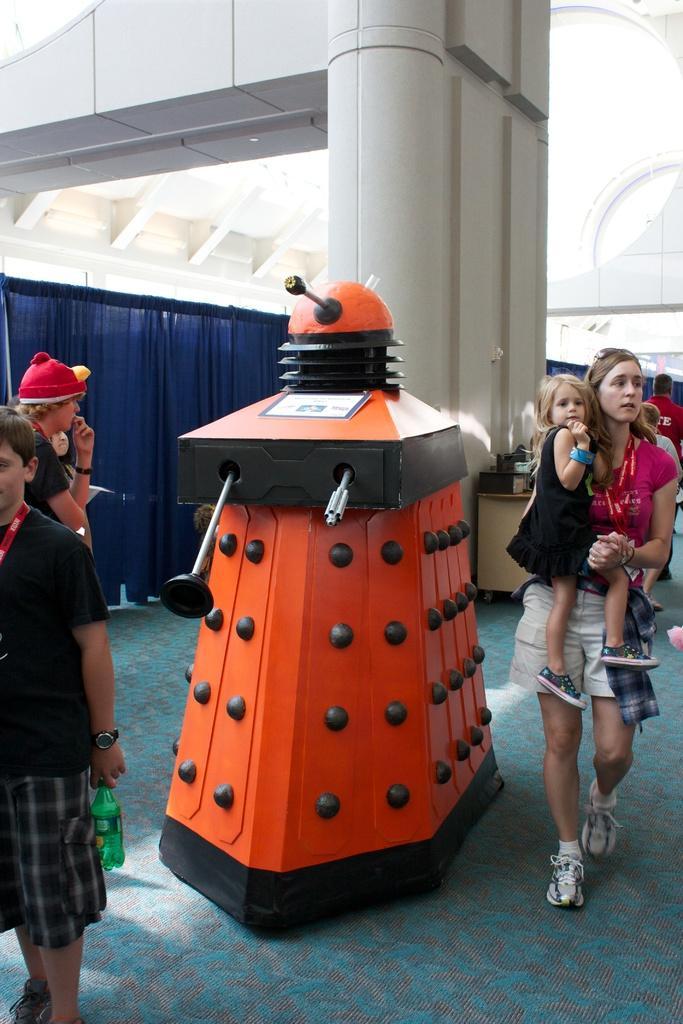Can you describe this image briefly? In this picture we can see an orange and a black object on the ground. There is a woman carrying a baby in her hand and walking on the ground. We can see a person holding a bottle in his hand on the left side. There are a few people visible at the back. We can see a blue curtain on the left side. A pillar is visible at the back. There are a few... 